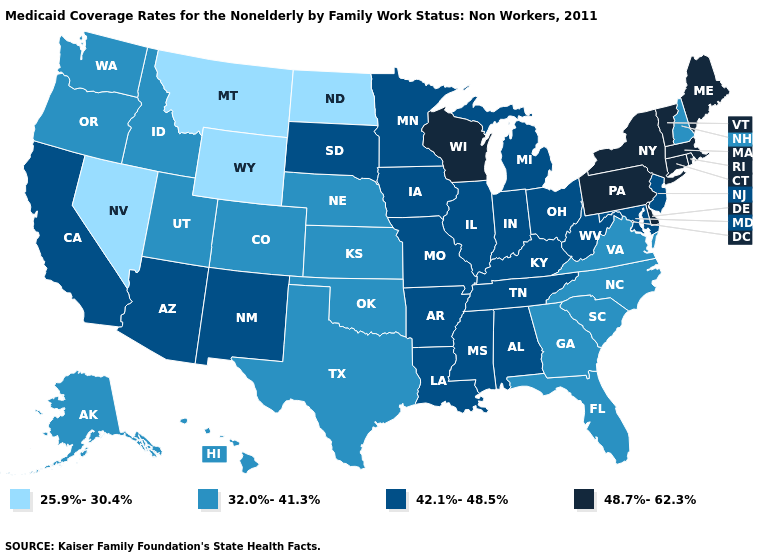Does Ohio have the lowest value in the MidWest?
Be succinct. No. What is the value of Montana?
Short answer required. 25.9%-30.4%. What is the highest value in the MidWest ?
Quick response, please. 48.7%-62.3%. What is the lowest value in the West?
Concise answer only. 25.9%-30.4%. Which states have the lowest value in the USA?
Write a very short answer. Montana, Nevada, North Dakota, Wyoming. Among the states that border New Jersey , which have the highest value?
Short answer required. Delaware, New York, Pennsylvania. Does New Hampshire have the lowest value in the Northeast?
Give a very brief answer. Yes. What is the value of West Virginia?
Short answer required. 42.1%-48.5%. Is the legend a continuous bar?
Keep it brief. No. What is the value of Hawaii?
Quick response, please. 32.0%-41.3%. Does New York have the highest value in the Northeast?
Quick response, please. Yes. Name the states that have a value in the range 48.7%-62.3%?
Keep it brief. Connecticut, Delaware, Maine, Massachusetts, New York, Pennsylvania, Rhode Island, Vermont, Wisconsin. Which states have the lowest value in the USA?
Keep it brief. Montana, Nevada, North Dakota, Wyoming. Does Maine have a higher value than New Jersey?
Answer briefly. Yes. What is the highest value in the Northeast ?
Answer briefly. 48.7%-62.3%. 